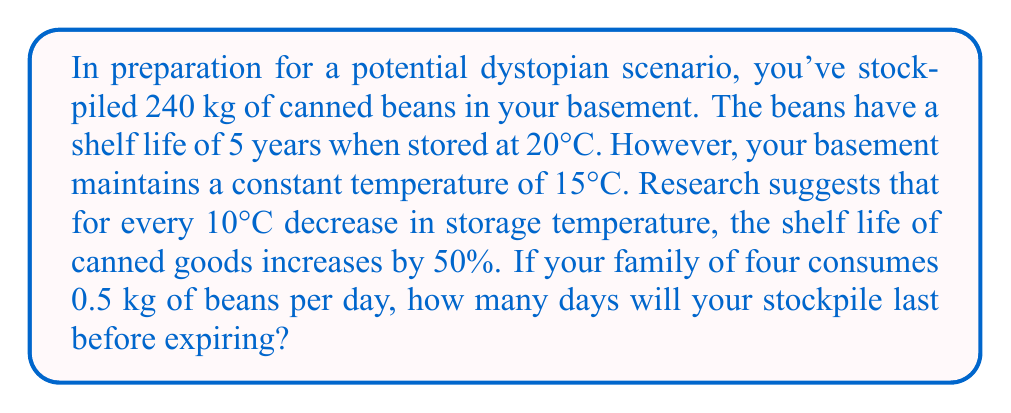Give your solution to this math problem. Let's approach this problem step-by-step:

1. Calculate the extended shelf life:
   - Temperature difference: $20°C - 15°C = 5°C$
   - Shelf life increase: $50\% \times \frac{5°C}{10°C} = 25\%$
   - New shelf life: $5 \text{ years} \times 1.25 = 6.25 \text{ years}$

2. Convert shelf life to days:
   $6.25 \text{ years} \times 365 \text{ days/year} = 2281.25 \text{ days}$

3. Calculate daily consumption rate:
   $0.5 \text{ kg/day} \times 4 \text{ people} = 2 \text{ kg/day}$

4. Calculate how long the stockpile will last:
   $\frac{240 \text{ kg}}{2 \text{ kg/day}} = 120 \text{ days}$

5. Compare stockpile duration to shelf life:
   Since 120 days is less than 2281.25 days, the stockpile will be consumed before it expires.

Therefore, the stockpile will last 120 days.
Answer: 120 days 